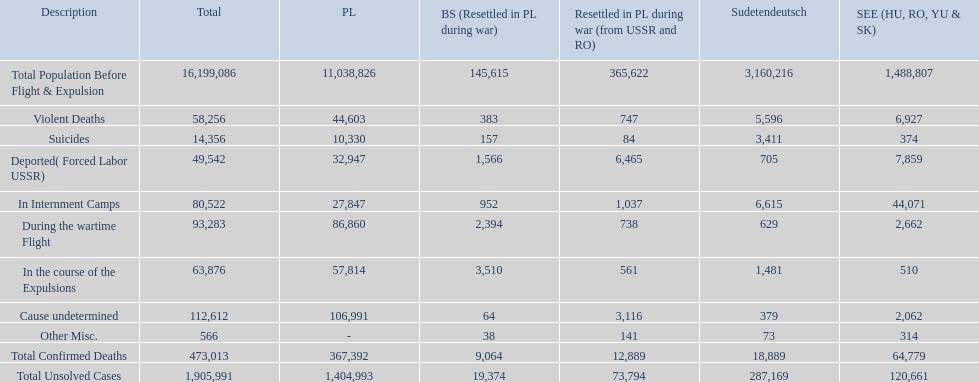What is the dissimilarity between suicides in poland and sudetendeutsch? 6919. Can you give me this table as a dict? {'header': ['Description', 'Total', 'PL', 'BS (Resettled in PL during war)', 'Resettled in PL during war (from USSR and RO)', 'Sudetendeutsch', 'SEE (HU, RO, YU & SK)'], 'rows': [['Total Population Before Flight & Expulsion', '16,199,086', '11,038,826', '145,615', '365,622', '3,160,216', '1,488,807'], ['Violent Deaths', '58,256', '44,603', '383', '747', '5,596', '6,927'], ['Suicides', '14,356', '10,330', '157', '84', '3,411', '374'], ['Deported( Forced Labor USSR)', '49,542', '32,947', '1,566', '6,465', '705', '7,859'], ['In Internment Camps', '80,522', '27,847', '952', '1,037', '6,615', '44,071'], ['During the wartime Flight', '93,283', '86,860', '2,394', '738', '629', '2,662'], ['In the course of the Expulsions', '63,876', '57,814', '3,510', '561', '1,481', '510'], ['Cause undetermined', '112,612', '106,991', '64', '3,116', '379', '2,062'], ['Other Misc.', '566', '-', '38', '141', '73', '314'], ['Total Confirmed Deaths', '473,013', '367,392', '9,064', '12,889', '18,889', '64,779'], ['Total Unsolved Cases', '1,905,991', '1,404,993', '19,374', '73,794', '287,169', '120,661']]} 